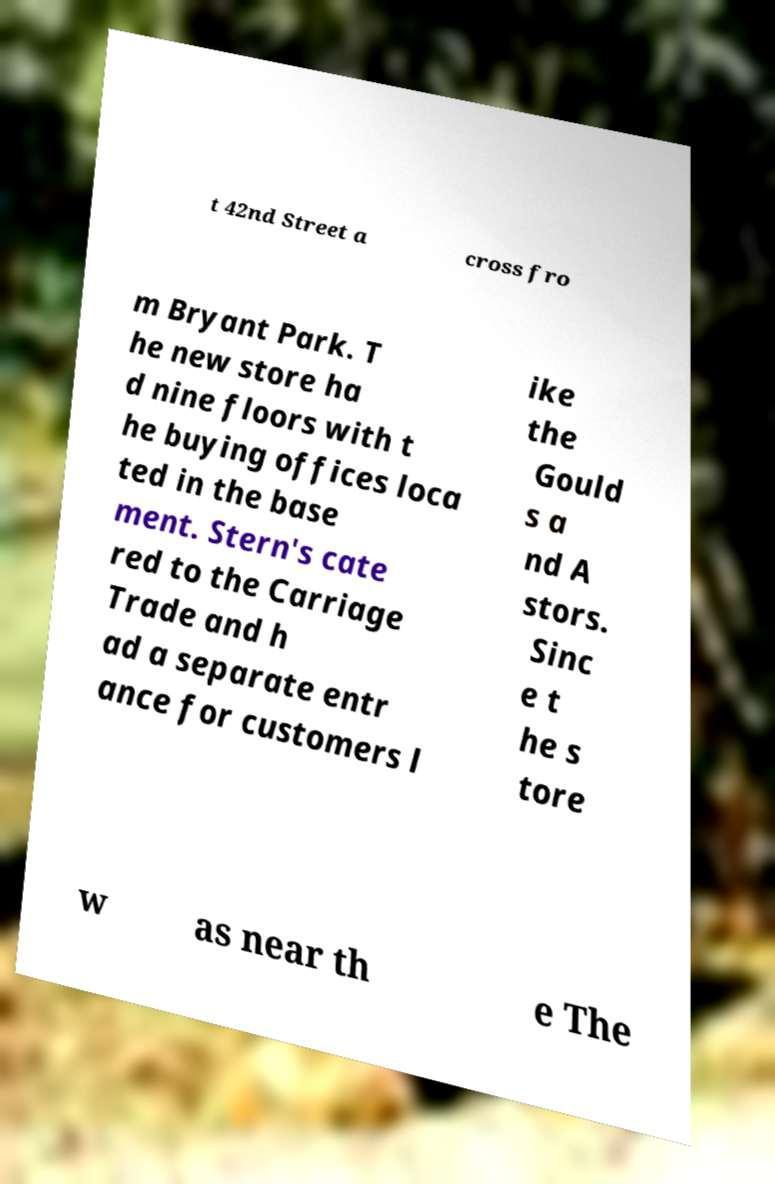Please read and relay the text visible in this image. What does it say? t 42nd Street a cross fro m Bryant Park. T he new store ha d nine floors with t he buying offices loca ted in the base ment. Stern's cate red to the Carriage Trade and h ad a separate entr ance for customers l ike the Gould s a nd A stors. Sinc e t he s tore w as near th e The 